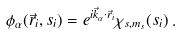<formula> <loc_0><loc_0><loc_500><loc_500>\phi _ { \alpha } ( \vec { r } _ { i } , s _ { i } ) = e ^ { i \vec { k } _ { \alpha } \cdot \vec { r } _ { i } } \chi _ { s , m _ { s } } ( s _ { i } ) \, .</formula> 